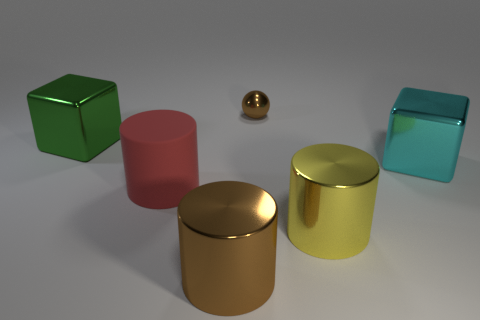Subtract 1 cylinders. How many cylinders are left? 2 Add 3 cyan metallic things. How many objects exist? 9 Subtract all blocks. How many objects are left? 4 Add 6 large cyan objects. How many large cyan objects exist? 7 Subtract 0 green balls. How many objects are left? 6 Subtract all cyan cubes. Subtract all large red cylinders. How many objects are left? 4 Add 2 rubber cylinders. How many rubber cylinders are left? 3 